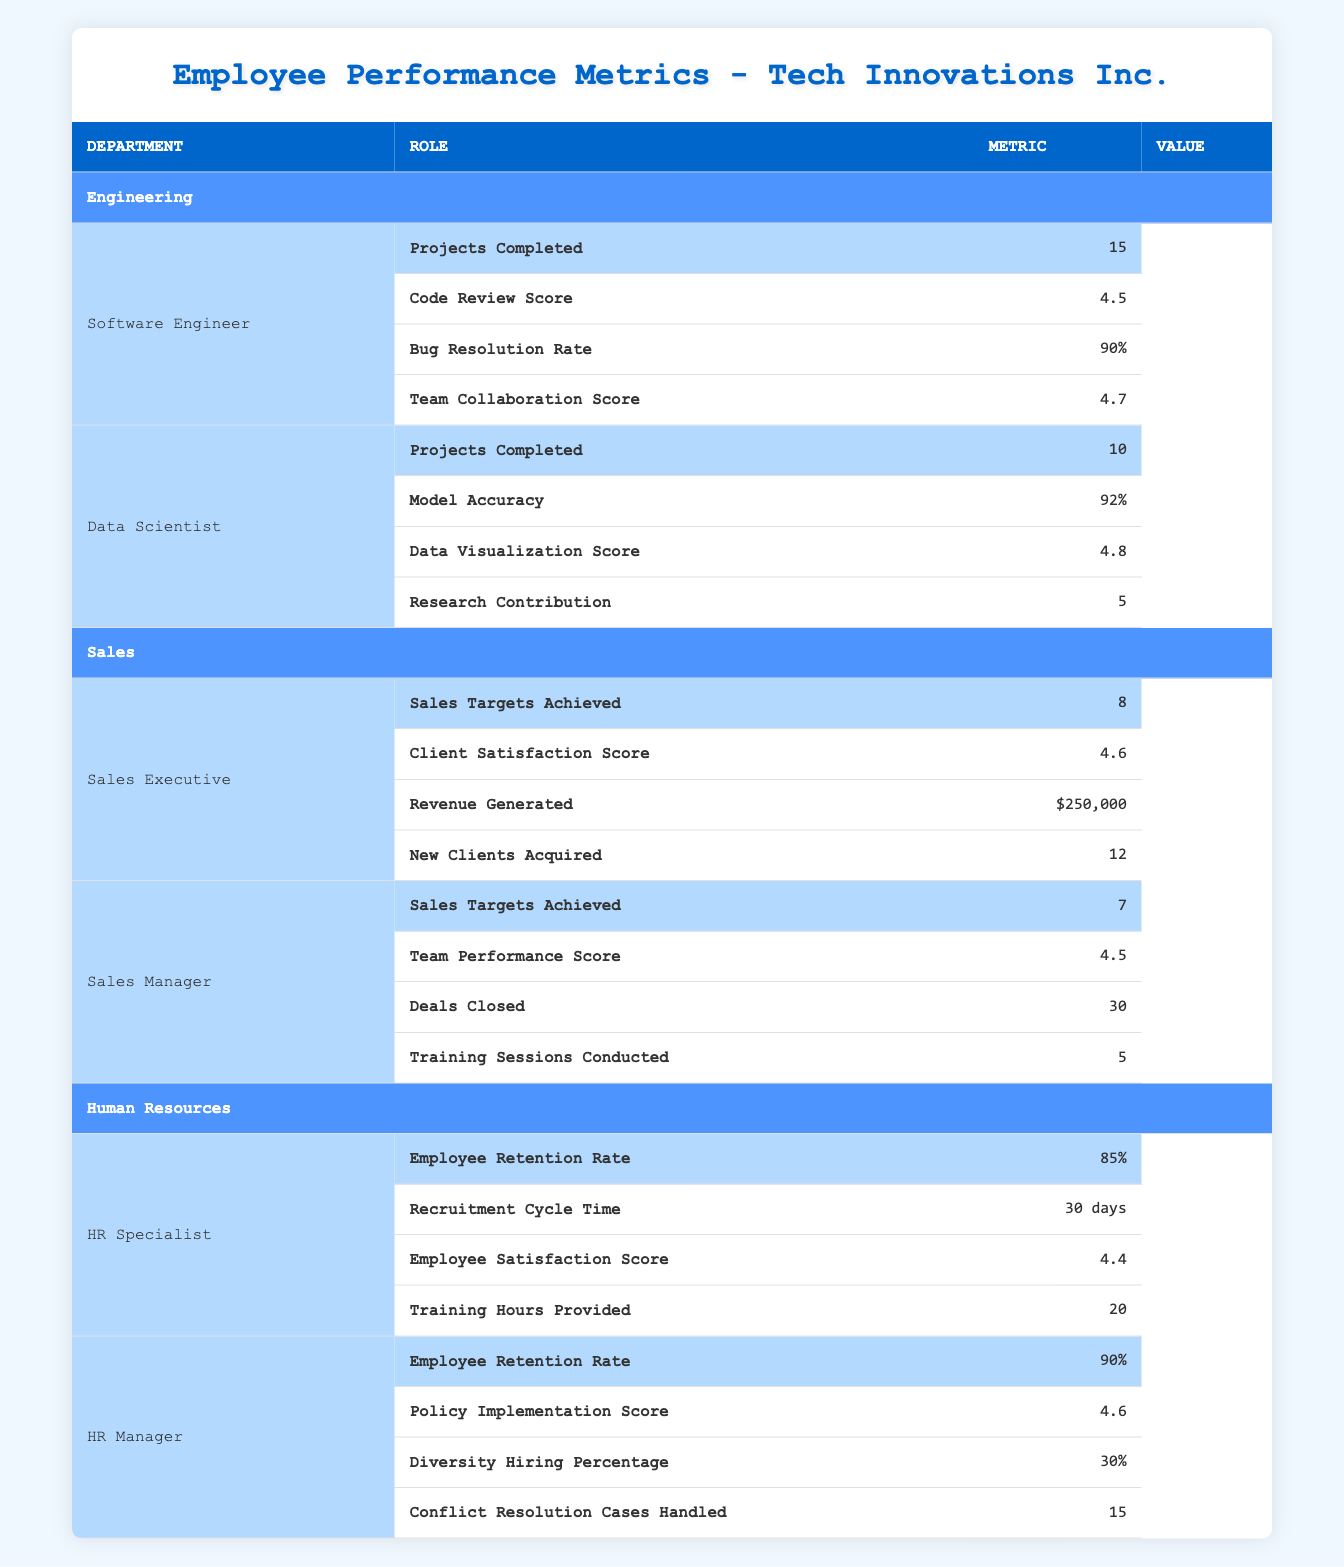What is the highest Code Review Score among the Engineering roles? In the Engineering department, the Software Engineer has a Code Review Score of 4.5 and the Data Scientist has a Data Visualization Score of 4.8. The Code Review Score for the Software Engineer is the only relevant metric here since the Data Scientist does not have a Code Review Score. Therefore, the highest Code Review Score is 4.5.
Answer: 4.5 How many projects did the Data Scientist complete? Referring to the Data Scientist under the Engineering department, the table shows that they completed 10 projects.
Answer: 10 Did the HR Specialist achieve a higher Employee Retention Rate than the HR Manager? The HR Specialist has an Employee Retention Rate of 85% while the HR Manager has an Employee Retention Rate of 90%. Thus, the HR Specialist did not achieve a higher rate than the HR Manager.
Answer: No What is the total number of new clients acquired by both Sales roles? The Sales Executive acquired 12 new clients, and the Sales Manager's data for new clients is not provided. Since only the Sales Executive's acquisition is available, the total new clients acquired by both roles is 12.
Answer: 12 What is the average Bug Resolution Rate of the Engineering roles? The Software Engineer has a Bug Resolution Rate of 90%. The Data Scientist does not have a corresponding Bug Resolution Rate value available, which means the average here is only based on the Software Engineer's rate, giving us an average of 90%.
Answer: 90% What is the difference in Sales Targets Achieved between the Sales Executive and Sales Manager? The Sales Executive achieved 8 sales targets while the Sales Manager achieved 7 targets. The difference is calculated by subtracting the Sales Manager's targets from the Sales Executive’s: 8 - 7 = 1.
Answer: 1 Which role in Human Resources has a higher Employee Satisfaction Score? The HR Specialist has an Employee Satisfaction Score of 4.4, while the HR Manager has a Policy Implementation Score instead of Employee Satisfaction. Therefore, we can only compare it to the HR Specialist, indicating the HR Specialist has the relative higher satisfaction score available.
Answer: HR Specialist 